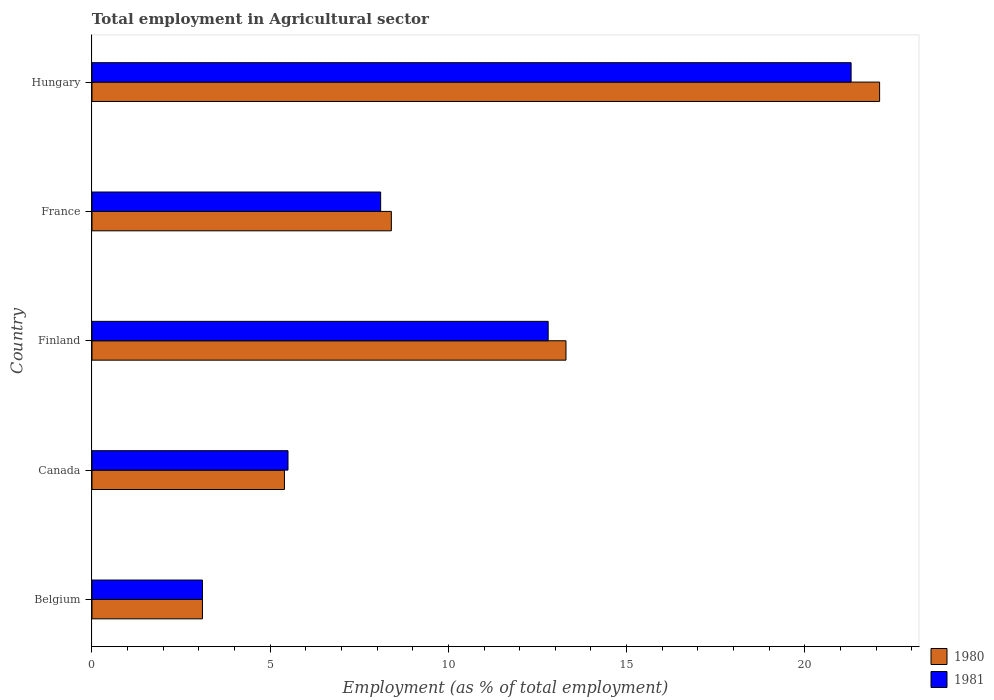How many different coloured bars are there?
Provide a short and direct response. 2. How many groups of bars are there?
Provide a succinct answer. 5. How many bars are there on the 3rd tick from the bottom?
Give a very brief answer. 2. What is the label of the 3rd group of bars from the top?
Provide a short and direct response. Finland. Across all countries, what is the maximum employment in agricultural sector in 1981?
Give a very brief answer. 21.3. Across all countries, what is the minimum employment in agricultural sector in 1981?
Provide a succinct answer. 3.1. In which country was the employment in agricultural sector in 1981 maximum?
Provide a succinct answer. Hungary. What is the total employment in agricultural sector in 1980 in the graph?
Make the answer very short. 52.3. What is the difference between the employment in agricultural sector in 1980 in Belgium and that in Hungary?
Provide a succinct answer. -19. What is the difference between the employment in agricultural sector in 1980 in Canada and the employment in agricultural sector in 1981 in Hungary?
Offer a very short reply. -15.9. What is the average employment in agricultural sector in 1980 per country?
Keep it short and to the point. 10.46. What is the ratio of the employment in agricultural sector in 1981 in Belgium to that in Finland?
Make the answer very short. 0.24. Is the employment in agricultural sector in 1981 in Belgium less than that in Canada?
Offer a terse response. Yes. Is the difference between the employment in agricultural sector in 1981 in Canada and Finland greater than the difference between the employment in agricultural sector in 1980 in Canada and Finland?
Your response must be concise. Yes. What is the difference between the highest and the second highest employment in agricultural sector in 1980?
Your response must be concise. 8.8. What is the difference between the highest and the lowest employment in agricultural sector in 1980?
Your answer should be compact. 19. In how many countries, is the employment in agricultural sector in 1980 greater than the average employment in agricultural sector in 1980 taken over all countries?
Offer a terse response. 2. What does the 2nd bar from the bottom in Finland represents?
Provide a short and direct response. 1981. Are all the bars in the graph horizontal?
Offer a terse response. Yes. Are the values on the major ticks of X-axis written in scientific E-notation?
Ensure brevity in your answer.  No. Does the graph contain any zero values?
Your answer should be very brief. No. Where does the legend appear in the graph?
Your response must be concise. Bottom right. How many legend labels are there?
Provide a short and direct response. 2. How are the legend labels stacked?
Provide a short and direct response. Vertical. What is the title of the graph?
Your answer should be compact. Total employment in Agricultural sector. What is the label or title of the X-axis?
Ensure brevity in your answer.  Employment (as % of total employment). What is the label or title of the Y-axis?
Make the answer very short. Country. What is the Employment (as % of total employment) of 1980 in Belgium?
Keep it short and to the point. 3.1. What is the Employment (as % of total employment) in 1981 in Belgium?
Your response must be concise. 3.1. What is the Employment (as % of total employment) in 1980 in Canada?
Make the answer very short. 5.4. What is the Employment (as % of total employment) in 1980 in Finland?
Offer a very short reply. 13.3. What is the Employment (as % of total employment) of 1981 in Finland?
Ensure brevity in your answer.  12.8. What is the Employment (as % of total employment) in 1980 in France?
Give a very brief answer. 8.4. What is the Employment (as % of total employment) of 1981 in France?
Offer a very short reply. 8.1. What is the Employment (as % of total employment) of 1980 in Hungary?
Ensure brevity in your answer.  22.1. What is the Employment (as % of total employment) of 1981 in Hungary?
Offer a terse response. 21.3. Across all countries, what is the maximum Employment (as % of total employment) in 1980?
Your answer should be very brief. 22.1. Across all countries, what is the maximum Employment (as % of total employment) of 1981?
Your answer should be compact. 21.3. Across all countries, what is the minimum Employment (as % of total employment) of 1980?
Your answer should be compact. 3.1. Across all countries, what is the minimum Employment (as % of total employment) of 1981?
Offer a very short reply. 3.1. What is the total Employment (as % of total employment) of 1980 in the graph?
Ensure brevity in your answer.  52.3. What is the total Employment (as % of total employment) in 1981 in the graph?
Give a very brief answer. 50.8. What is the difference between the Employment (as % of total employment) in 1981 in Belgium and that in Canada?
Offer a terse response. -2.4. What is the difference between the Employment (as % of total employment) of 1981 in Belgium and that in France?
Give a very brief answer. -5. What is the difference between the Employment (as % of total employment) in 1981 in Belgium and that in Hungary?
Your answer should be very brief. -18.2. What is the difference between the Employment (as % of total employment) in 1980 in Canada and that in Finland?
Provide a short and direct response. -7.9. What is the difference between the Employment (as % of total employment) in 1980 in Canada and that in France?
Keep it short and to the point. -3. What is the difference between the Employment (as % of total employment) of 1980 in Canada and that in Hungary?
Offer a terse response. -16.7. What is the difference between the Employment (as % of total employment) in 1981 in Canada and that in Hungary?
Offer a very short reply. -15.8. What is the difference between the Employment (as % of total employment) of 1980 in Finland and that in France?
Give a very brief answer. 4.9. What is the difference between the Employment (as % of total employment) of 1981 in Finland and that in France?
Your answer should be very brief. 4.7. What is the difference between the Employment (as % of total employment) of 1980 in Finland and that in Hungary?
Provide a succinct answer. -8.8. What is the difference between the Employment (as % of total employment) in 1981 in Finland and that in Hungary?
Offer a terse response. -8.5. What is the difference between the Employment (as % of total employment) of 1980 in France and that in Hungary?
Your answer should be compact. -13.7. What is the difference between the Employment (as % of total employment) in 1981 in France and that in Hungary?
Offer a terse response. -13.2. What is the difference between the Employment (as % of total employment) in 1980 in Belgium and the Employment (as % of total employment) in 1981 in Hungary?
Make the answer very short. -18.2. What is the difference between the Employment (as % of total employment) in 1980 in Canada and the Employment (as % of total employment) in 1981 in Finland?
Your response must be concise. -7.4. What is the difference between the Employment (as % of total employment) in 1980 in Canada and the Employment (as % of total employment) in 1981 in Hungary?
Provide a short and direct response. -15.9. What is the average Employment (as % of total employment) in 1980 per country?
Ensure brevity in your answer.  10.46. What is the average Employment (as % of total employment) of 1981 per country?
Provide a short and direct response. 10.16. What is the difference between the Employment (as % of total employment) of 1980 and Employment (as % of total employment) of 1981 in Belgium?
Offer a very short reply. 0. What is the difference between the Employment (as % of total employment) in 1980 and Employment (as % of total employment) in 1981 in Canada?
Ensure brevity in your answer.  -0.1. What is the difference between the Employment (as % of total employment) in 1980 and Employment (as % of total employment) in 1981 in Finland?
Keep it short and to the point. 0.5. What is the difference between the Employment (as % of total employment) of 1980 and Employment (as % of total employment) of 1981 in Hungary?
Your response must be concise. 0.8. What is the ratio of the Employment (as % of total employment) of 1980 in Belgium to that in Canada?
Provide a succinct answer. 0.57. What is the ratio of the Employment (as % of total employment) in 1981 in Belgium to that in Canada?
Ensure brevity in your answer.  0.56. What is the ratio of the Employment (as % of total employment) in 1980 in Belgium to that in Finland?
Your response must be concise. 0.23. What is the ratio of the Employment (as % of total employment) of 1981 in Belgium to that in Finland?
Your answer should be very brief. 0.24. What is the ratio of the Employment (as % of total employment) of 1980 in Belgium to that in France?
Offer a very short reply. 0.37. What is the ratio of the Employment (as % of total employment) in 1981 in Belgium to that in France?
Your response must be concise. 0.38. What is the ratio of the Employment (as % of total employment) in 1980 in Belgium to that in Hungary?
Your answer should be compact. 0.14. What is the ratio of the Employment (as % of total employment) in 1981 in Belgium to that in Hungary?
Provide a short and direct response. 0.15. What is the ratio of the Employment (as % of total employment) of 1980 in Canada to that in Finland?
Provide a succinct answer. 0.41. What is the ratio of the Employment (as % of total employment) in 1981 in Canada to that in Finland?
Ensure brevity in your answer.  0.43. What is the ratio of the Employment (as % of total employment) of 1980 in Canada to that in France?
Keep it short and to the point. 0.64. What is the ratio of the Employment (as % of total employment) of 1981 in Canada to that in France?
Make the answer very short. 0.68. What is the ratio of the Employment (as % of total employment) in 1980 in Canada to that in Hungary?
Provide a short and direct response. 0.24. What is the ratio of the Employment (as % of total employment) of 1981 in Canada to that in Hungary?
Keep it short and to the point. 0.26. What is the ratio of the Employment (as % of total employment) of 1980 in Finland to that in France?
Your answer should be very brief. 1.58. What is the ratio of the Employment (as % of total employment) of 1981 in Finland to that in France?
Keep it short and to the point. 1.58. What is the ratio of the Employment (as % of total employment) of 1980 in Finland to that in Hungary?
Offer a terse response. 0.6. What is the ratio of the Employment (as % of total employment) in 1981 in Finland to that in Hungary?
Offer a very short reply. 0.6. What is the ratio of the Employment (as % of total employment) of 1980 in France to that in Hungary?
Your answer should be very brief. 0.38. What is the ratio of the Employment (as % of total employment) of 1981 in France to that in Hungary?
Provide a short and direct response. 0.38. 